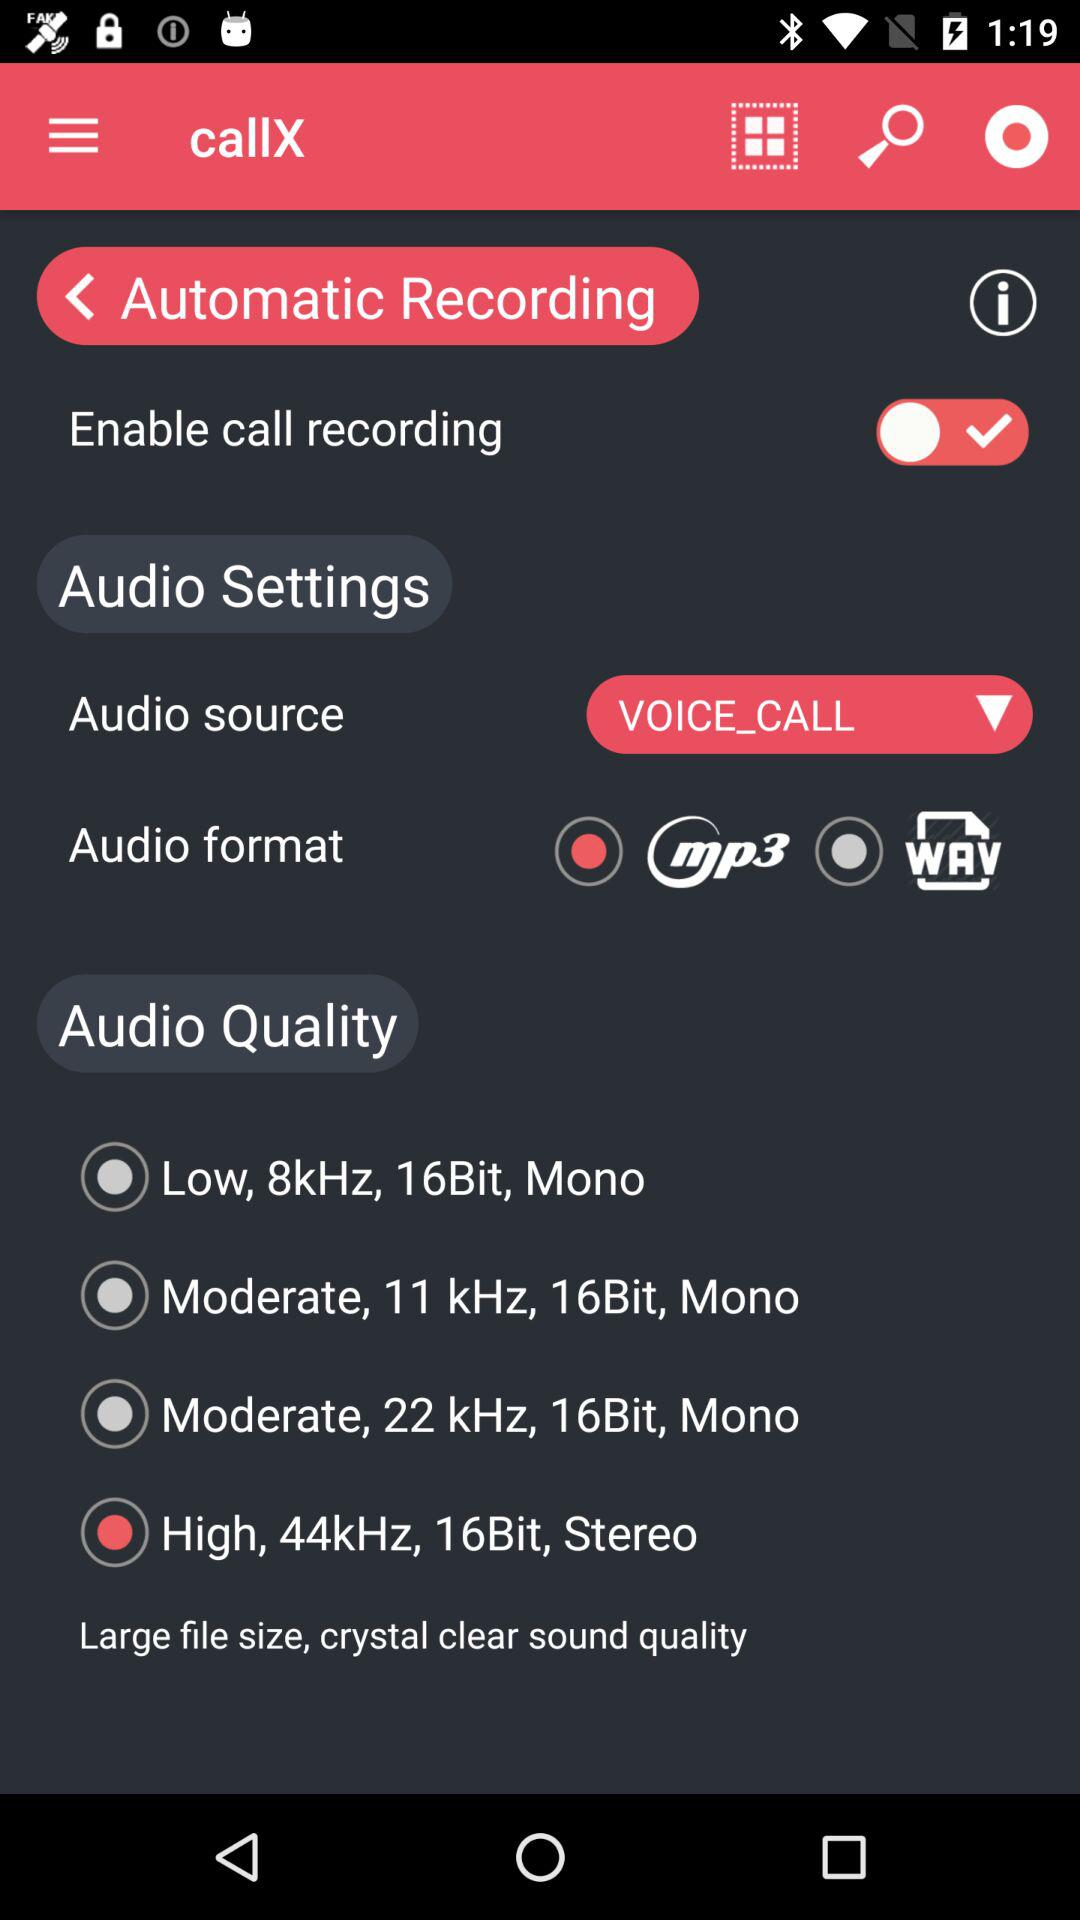What is the status of "Enable call recording"? The status of "Enable call recording" is "on". 